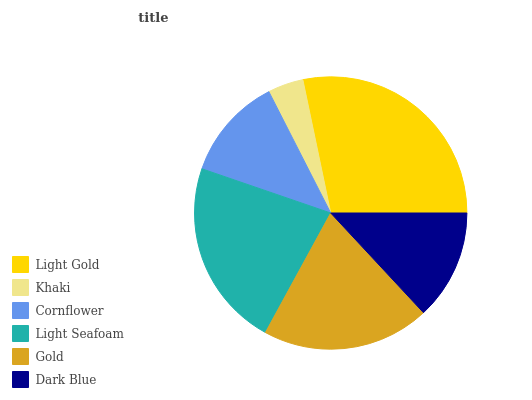Is Khaki the minimum?
Answer yes or no. Yes. Is Light Gold the maximum?
Answer yes or no. Yes. Is Cornflower the minimum?
Answer yes or no. No. Is Cornflower the maximum?
Answer yes or no. No. Is Cornflower greater than Khaki?
Answer yes or no. Yes. Is Khaki less than Cornflower?
Answer yes or no. Yes. Is Khaki greater than Cornflower?
Answer yes or no. No. Is Cornflower less than Khaki?
Answer yes or no. No. Is Gold the high median?
Answer yes or no. Yes. Is Dark Blue the low median?
Answer yes or no. Yes. Is Cornflower the high median?
Answer yes or no. No. Is Light Gold the low median?
Answer yes or no. No. 